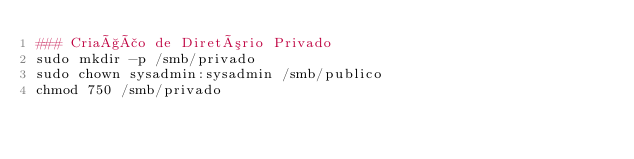<code> <loc_0><loc_0><loc_500><loc_500><_Bash_>### Criação de Diretório Privado
sudo mkdir -p /smb/privado
sudo chown sysadmin:sysadmin /smb/publico
chmod 750 /smb/privado</code> 